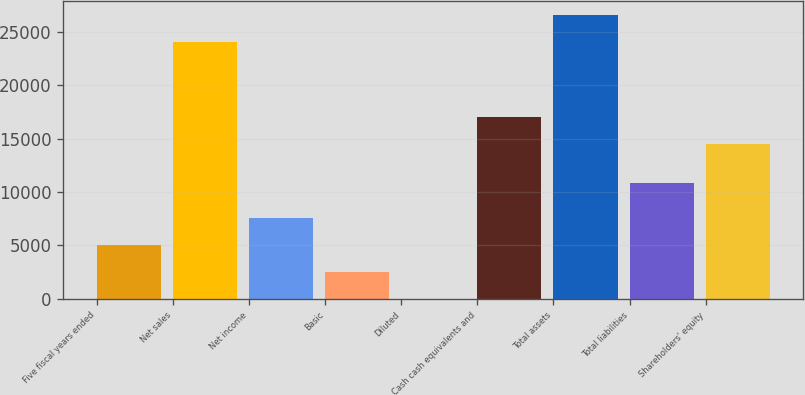<chart> <loc_0><loc_0><loc_500><loc_500><bar_chart><fcel>Five fiscal years ended<fcel>Net sales<fcel>Net income<fcel>Basic<fcel>Diluted<fcel>Cash cash equivalents and<fcel>Total assets<fcel>Total liabilities<fcel>Shareholders' equity<nl><fcel>5072.55<fcel>24006<fcel>7606.86<fcel>2538.24<fcel>3.93<fcel>17066.3<fcel>26540.3<fcel>10815<fcel>14532<nl></chart> 